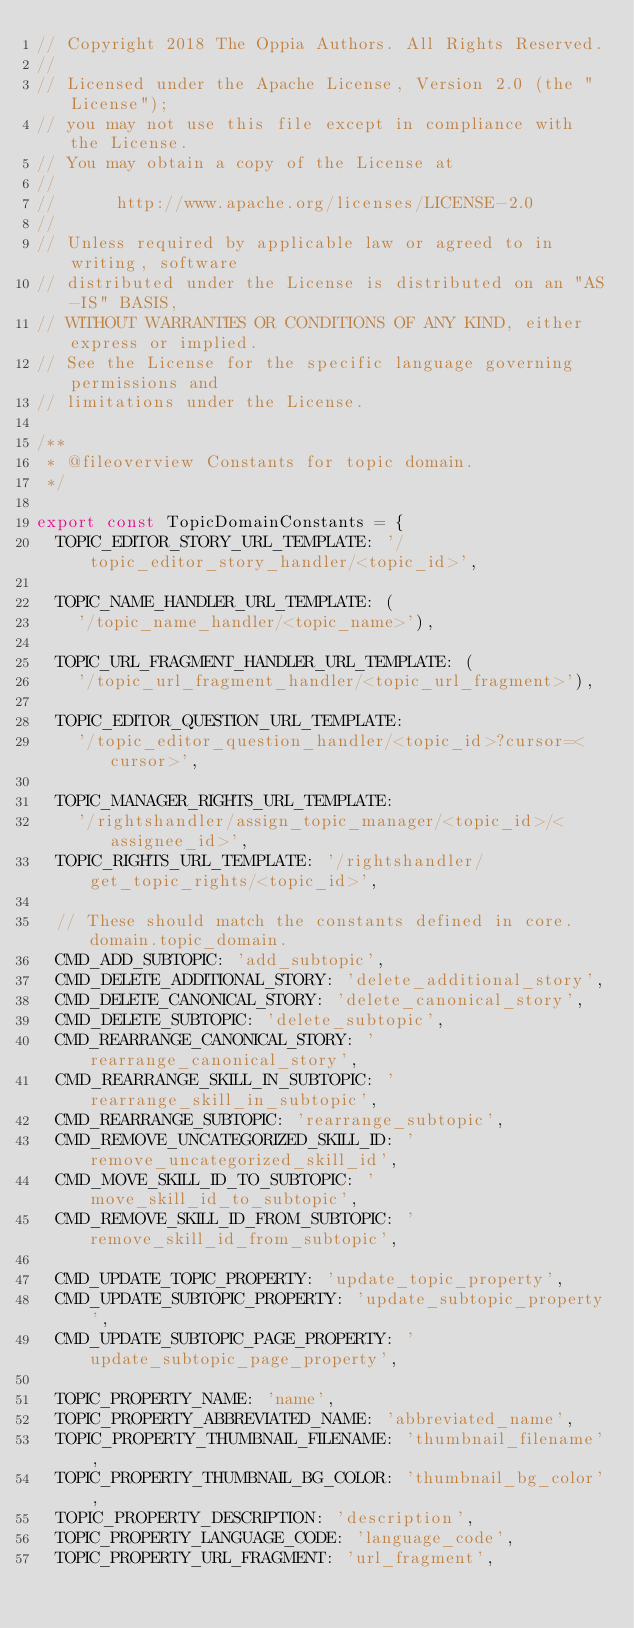Convert code to text. <code><loc_0><loc_0><loc_500><loc_500><_TypeScript_>// Copyright 2018 The Oppia Authors. All Rights Reserved.
//
// Licensed under the Apache License, Version 2.0 (the "License");
// you may not use this file except in compliance with the License.
// You may obtain a copy of the License at
//
//      http://www.apache.org/licenses/LICENSE-2.0
//
// Unless required by applicable law or agreed to in writing, software
// distributed under the License is distributed on an "AS-IS" BASIS,
// WITHOUT WARRANTIES OR CONDITIONS OF ANY KIND, either express or implied.
// See the License for the specific language governing permissions and
// limitations under the License.

/**
 * @fileoverview Constants for topic domain.
 */

export const TopicDomainConstants = {
  TOPIC_EDITOR_STORY_URL_TEMPLATE: '/topic_editor_story_handler/<topic_id>',

  TOPIC_NAME_HANDLER_URL_TEMPLATE: (
    '/topic_name_handler/<topic_name>'),

  TOPIC_URL_FRAGMENT_HANDLER_URL_TEMPLATE: (
    '/topic_url_fragment_handler/<topic_url_fragment>'),

  TOPIC_EDITOR_QUESTION_URL_TEMPLATE:
    '/topic_editor_question_handler/<topic_id>?cursor=<cursor>',

  TOPIC_MANAGER_RIGHTS_URL_TEMPLATE:
    '/rightshandler/assign_topic_manager/<topic_id>/<assignee_id>',
  TOPIC_RIGHTS_URL_TEMPLATE: '/rightshandler/get_topic_rights/<topic_id>',

  // These should match the constants defined in core.domain.topic_domain.
  CMD_ADD_SUBTOPIC: 'add_subtopic',
  CMD_DELETE_ADDITIONAL_STORY: 'delete_additional_story',
  CMD_DELETE_CANONICAL_STORY: 'delete_canonical_story',
  CMD_DELETE_SUBTOPIC: 'delete_subtopic',
  CMD_REARRANGE_CANONICAL_STORY: 'rearrange_canonical_story',
  CMD_REARRANGE_SKILL_IN_SUBTOPIC: 'rearrange_skill_in_subtopic',
  CMD_REARRANGE_SUBTOPIC: 'rearrange_subtopic',
  CMD_REMOVE_UNCATEGORIZED_SKILL_ID: 'remove_uncategorized_skill_id',
  CMD_MOVE_SKILL_ID_TO_SUBTOPIC: 'move_skill_id_to_subtopic',
  CMD_REMOVE_SKILL_ID_FROM_SUBTOPIC: 'remove_skill_id_from_subtopic',

  CMD_UPDATE_TOPIC_PROPERTY: 'update_topic_property',
  CMD_UPDATE_SUBTOPIC_PROPERTY: 'update_subtopic_property',
  CMD_UPDATE_SUBTOPIC_PAGE_PROPERTY: 'update_subtopic_page_property',

  TOPIC_PROPERTY_NAME: 'name',
  TOPIC_PROPERTY_ABBREVIATED_NAME: 'abbreviated_name',
  TOPIC_PROPERTY_THUMBNAIL_FILENAME: 'thumbnail_filename',
  TOPIC_PROPERTY_THUMBNAIL_BG_COLOR: 'thumbnail_bg_color',
  TOPIC_PROPERTY_DESCRIPTION: 'description',
  TOPIC_PROPERTY_LANGUAGE_CODE: 'language_code',
  TOPIC_PROPERTY_URL_FRAGMENT: 'url_fragment',</code> 